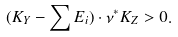<formula> <loc_0><loc_0><loc_500><loc_500>( K _ { Y } - \sum E _ { i } ) \cdot \nu ^ { * } K _ { Z } > 0 .</formula> 